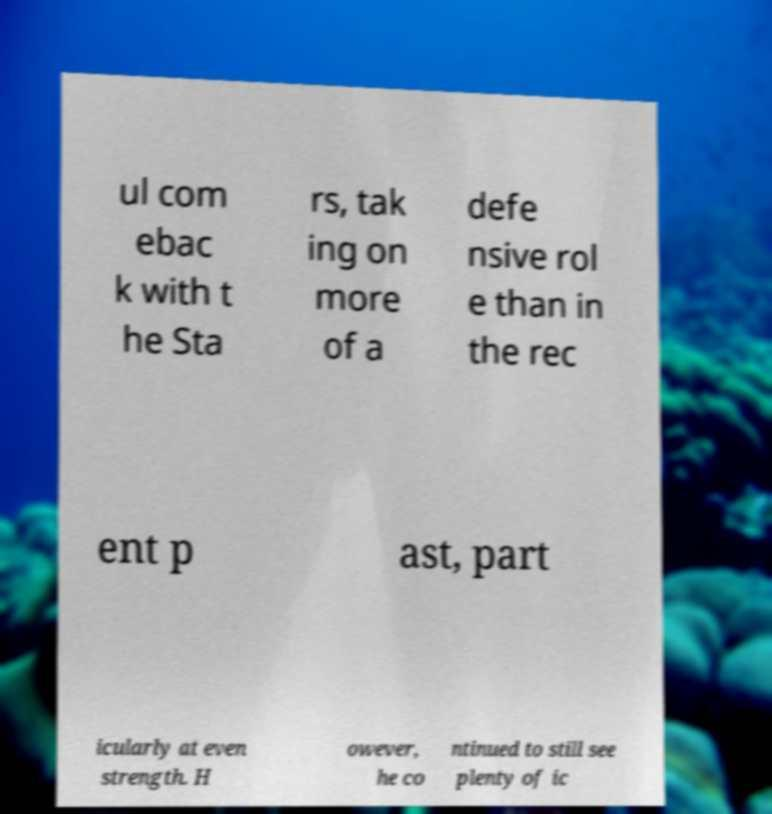Could you extract and type out the text from this image? ul com ebac k with t he Sta rs, tak ing on more of a defe nsive rol e than in the rec ent p ast, part icularly at even strength. H owever, he co ntinued to still see plenty of ic 